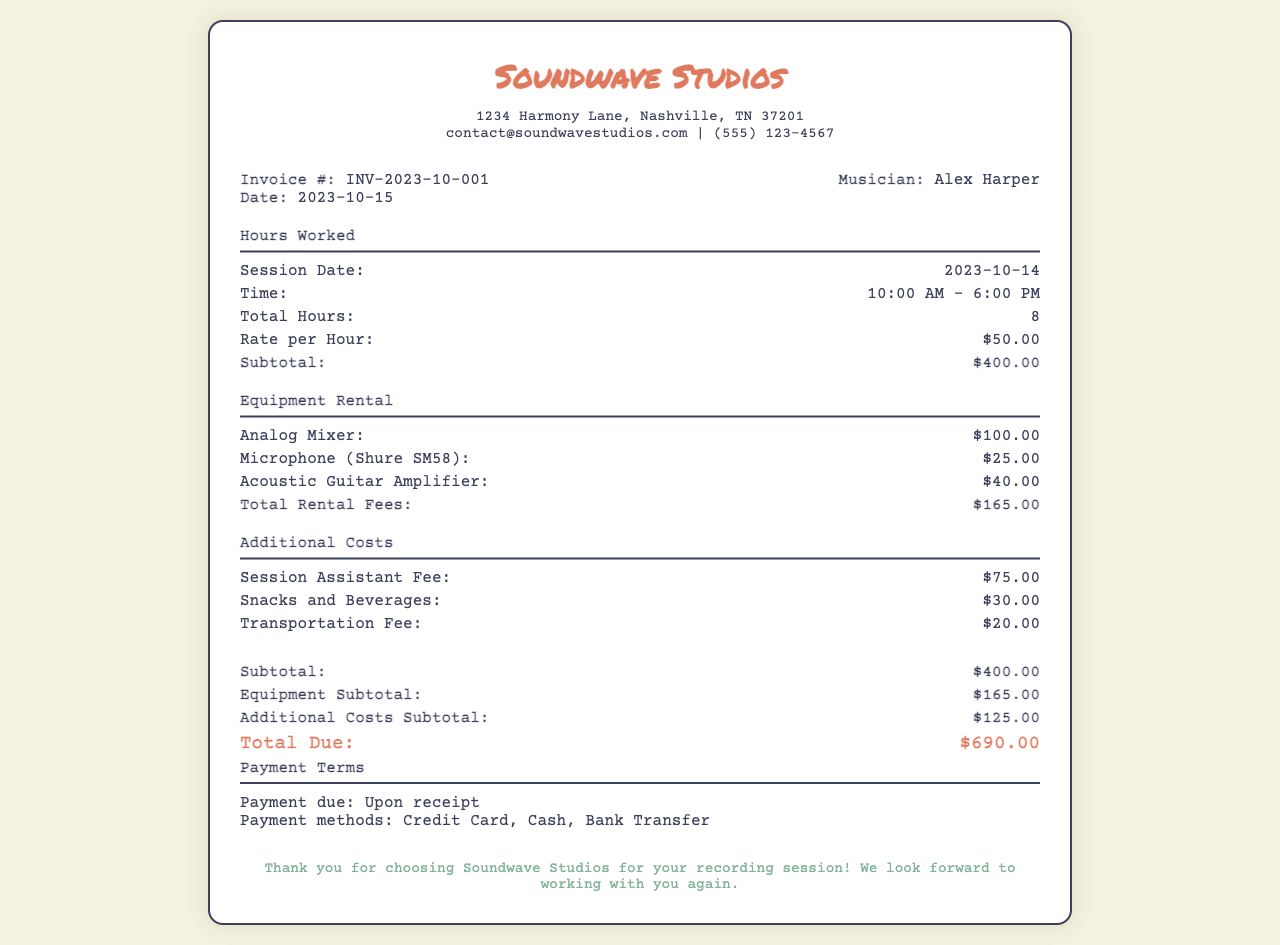What is the invoice number? The invoice number is listed in the document to uniquely identify it, which is INV-2023-10-001.
Answer: INV-2023-10-001 What is the date of the invoice? The date of the invoice can be found in the document, which is specified as 2023-10-15.
Answer: 2023-10-15 How many total hours were worked? The document specifies the total hours worked during the session, which is 8 hours.
Answer: 8 What is the rate per hour? The rate per hour for the recording session is provided in the document, which is $50.00.
Answer: $50.00 What is the total for equipment rental fees? The total amount for all equipment rental fees listed in the document is $165.00.
Answer: $165.00 What is the subtotal for additional costs? The document provides additional costs, and their subtotal is $125.00.
Answer: $125.00 What is the total amount due? The total due is the sum of all costs presented in the invoice, which is $690.00.
Answer: $690.00 What payment methods are accepted? The document lists the accepted payment methods, which include Credit Card, Cash, and Bank Transfer.
Answer: Credit Card, Cash, Bank Transfer What is the address of the studio? The studio address is mentioned in the document, which is 1234 Harmony Lane, Nashville, TN 37201.
Answer: 1234 Harmony Lane, Nashville, TN 37201 